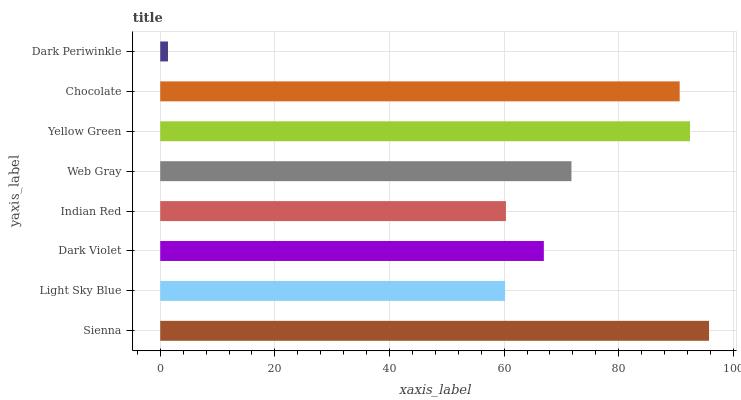Is Dark Periwinkle the minimum?
Answer yes or no. Yes. Is Sienna the maximum?
Answer yes or no. Yes. Is Light Sky Blue the minimum?
Answer yes or no. No. Is Light Sky Blue the maximum?
Answer yes or no. No. Is Sienna greater than Light Sky Blue?
Answer yes or no. Yes. Is Light Sky Blue less than Sienna?
Answer yes or no. Yes. Is Light Sky Blue greater than Sienna?
Answer yes or no. No. Is Sienna less than Light Sky Blue?
Answer yes or no. No. Is Web Gray the high median?
Answer yes or no. Yes. Is Dark Violet the low median?
Answer yes or no. Yes. Is Dark Periwinkle the high median?
Answer yes or no. No. Is Sienna the low median?
Answer yes or no. No. 